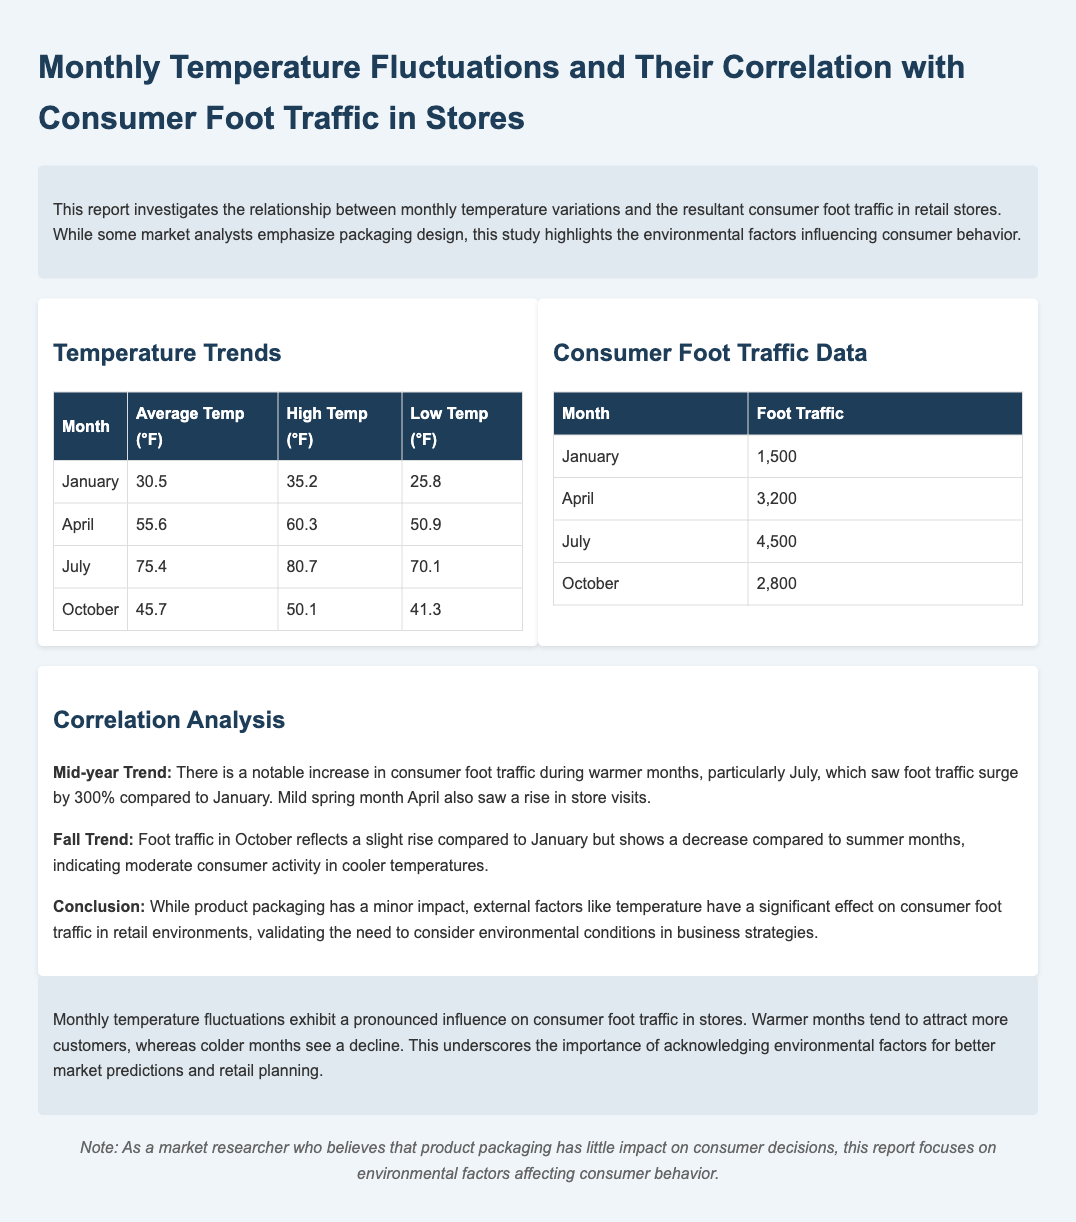What is the average temperature in July? The average temperature in July is listed in the temperature trends table as 75.4°F.
Answer: 75.4°F What was the foot traffic in January? The foot traffic in January is indicated as 1,500 in the consumer foot traffic data table.
Answer: 1,500 What correlation is noted for foot traffic during warmer months? The report states that there is a notable increase in consumer foot traffic during warmer months, particularly in July.
Answer: Notable increase What were the high and low temperatures in October? The high temperature in October is 50.1°F and the low temperature is 41.3°F, as displayed in the temperature trends table.
Answer: 50.1°F; 41.3°F How much did foot traffic increase from January to July? The report mentions a 300% increase in foot traffic from January to July, which is a significant observation in consumer behavior.
Answer: 300% What is the conclusion of the report regarding packaging? The conclusion emphasizes that while product packaging has a minor impact, external factors like temperature significantly affect foot traffic.
Answer: Minor impact Which month experienced the highest foot traffic? The month of July saw the highest foot traffic, as noted in the consumer foot traffic data table.
Answer: July What is the average temperature in April? The average temperature in April is stated to be 55.6°F in the temperature trends section.
Answer: 55.6°F What trend is observed in October foot traffic compared to January? The report notes that foot traffic in October shows a slight rise compared to January but is lower than in the summer months.
Answer: Slight rise 